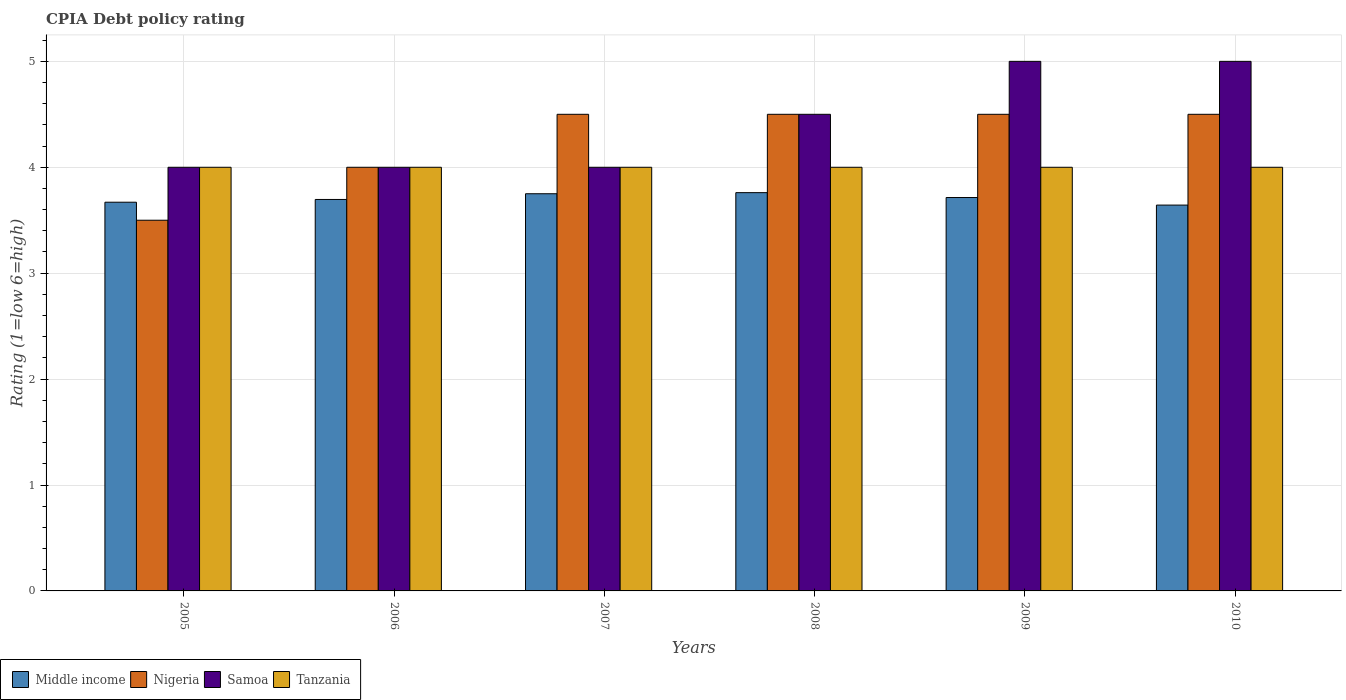How many different coloured bars are there?
Offer a very short reply. 4. Across all years, what is the maximum CPIA rating in Tanzania?
Ensure brevity in your answer.  4. Across all years, what is the minimum CPIA rating in Tanzania?
Your answer should be compact. 4. What is the total CPIA rating in Samoa in the graph?
Your answer should be compact. 26.5. What is the difference between the CPIA rating in Tanzania in 2005 and that in 2009?
Your answer should be very brief. 0. What is the difference between the CPIA rating in Tanzania in 2009 and the CPIA rating in Middle income in 2006?
Provide a succinct answer. 0.3. What is the average CPIA rating in Tanzania per year?
Offer a terse response. 4. What is the ratio of the CPIA rating in Samoa in 2007 to that in 2008?
Your answer should be very brief. 0.89. Is the difference between the CPIA rating in Nigeria in 2005 and 2006 greater than the difference between the CPIA rating in Samoa in 2005 and 2006?
Keep it short and to the point. No. What is the difference between the highest and the lowest CPIA rating in Nigeria?
Offer a terse response. 1. Is it the case that in every year, the sum of the CPIA rating in Middle income and CPIA rating in Tanzania is greater than the sum of CPIA rating in Samoa and CPIA rating in Nigeria?
Provide a succinct answer. No. What does the 3rd bar from the left in 2009 represents?
Keep it short and to the point. Samoa. What does the 3rd bar from the right in 2007 represents?
Your answer should be compact. Nigeria. How many bars are there?
Give a very brief answer. 24. Are all the bars in the graph horizontal?
Offer a very short reply. No. What is the difference between two consecutive major ticks on the Y-axis?
Your response must be concise. 1. Does the graph contain any zero values?
Ensure brevity in your answer.  No. Where does the legend appear in the graph?
Offer a terse response. Bottom left. What is the title of the graph?
Offer a very short reply. CPIA Debt policy rating. What is the label or title of the X-axis?
Make the answer very short. Years. What is the label or title of the Y-axis?
Provide a succinct answer. Rating (1=low 6=high). What is the Rating (1=low 6=high) in Middle income in 2005?
Ensure brevity in your answer.  3.67. What is the Rating (1=low 6=high) in Nigeria in 2005?
Provide a short and direct response. 3.5. What is the Rating (1=low 6=high) in Middle income in 2006?
Your response must be concise. 3.7. What is the Rating (1=low 6=high) in Nigeria in 2006?
Your answer should be very brief. 4. What is the Rating (1=low 6=high) of Samoa in 2006?
Your answer should be compact. 4. What is the Rating (1=low 6=high) of Tanzania in 2006?
Ensure brevity in your answer.  4. What is the Rating (1=low 6=high) of Middle income in 2007?
Your response must be concise. 3.75. What is the Rating (1=low 6=high) in Samoa in 2007?
Your answer should be compact. 4. What is the Rating (1=low 6=high) of Tanzania in 2007?
Make the answer very short. 4. What is the Rating (1=low 6=high) in Middle income in 2008?
Your answer should be compact. 3.76. What is the Rating (1=low 6=high) in Tanzania in 2008?
Make the answer very short. 4. What is the Rating (1=low 6=high) of Middle income in 2009?
Provide a short and direct response. 3.71. What is the Rating (1=low 6=high) of Middle income in 2010?
Offer a terse response. 3.64. What is the Rating (1=low 6=high) in Nigeria in 2010?
Provide a short and direct response. 4.5. Across all years, what is the maximum Rating (1=low 6=high) of Middle income?
Provide a short and direct response. 3.76. Across all years, what is the maximum Rating (1=low 6=high) in Nigeria?
Make the answer very short. 4.5. Across all years, what is the maximum Rating (1=low 6=high) in Samoa?
Your answer should be compact. 5. Across all years, what is the minimum Rating (1=low 6=high) in Middle income?
Your answer should be compact. 3.64. Across all years, what is the minimum Rating (1=low 6=high) of Nigeria?
Offer a very short reply. 3.5. Across all years, what is the minimum Rating (1=low 6=high) of Samoa?
Ensure brevity in your answer.  4. Across all years, what is the minimum Rating (1=low 6=high) of Tanzania?
Keep it short and to the point. 4. What is the total Rating (1=low 6=high) of Middle income in the graph?
Your answer should be compact. 22.23. What is the total Rating (1=low 6=high) of Samoa in the graph?
Your response must be concise. 26.5. What is the difference between the Rating (1=low 6=high) of Middle income in 2005 and that in 2006?
Offer a very short reply. -0.03. What is the difference between the Rating (1=low 6=high) in Nigeria in 2005 and that in 2006?
Ensure brevity in your answer.  -0.5. What is the difference between the Rating (1=low 6=high) of Samoa in 2005 and that in 2006?
Provide a short and direct response. 0. What is the difference between the Rating (1=low 6=high) in Tanzania in 2005 and that in 2006?
Offer a terse response. 0. What is the difference between the Rating (1=low 6=high) in Middle income in 2005 and that in 2007?
Make the answer very short. -0.08. What is the difference between the Rating (1=low 6=high) in Nigeria in 2005 and that in 2007?
Provide a succinct answer. -1. What is the difference between the Rating (1=low 6=high) of Tanzania in 2005 and that in 2007?
Your response must be concise. 0. What is the difference between the Rating (1=low 6=high) of Middle income in 2005 and that in 2008?
Keep it short and to the point. -0.09. What is the difference between the Rating (1=low 6=high) in Nigeria in 2005 and that in 2008?
Your answer should be compact. -1. What is the difference between the Rating (1=low 6=high) of Tanzania in 2005 and that in 2008?
Make the answer very short. 0. What is the difference between the Rating (1=low 6=high) in Middle income in 2005 and that in 2009?
Offer a very short reply. -0.04. What is the difference between the Rating (1=low 6=high) of Nigeria in 2005 and that in 2009?
Your answer should be very brief. -1. What is the difference between the Rating (1=low 6=high) in Middle income in 2005 and that in 2010?
Your answer should be compact. 0.03. What is the difference between the Rating (1=low 6=high) of Samoa in 2005 and that in 2010?
Your response must be concise. -1. What is the difference between the Rating (1=low 6=high) of Middle income in 2006 and that in 2007?
Keep it short and to the point. -0.05. What is the difference between the Rating (1=low 6=high) in Middle income in 2006 and that in 2008?
Ensure brevity in your answer.  -0.06. What is the difference between the Rating (1=low 6=high) in Nigeria in 2006 and that in 2008?
Provide a short and direct response. -0.5. What is the difference between the Rating (1=low 6=high) in Middle income in 2006 and that in 2009?
Provide a short and direct response. -0.02. What is the difference between the Rating (1=low 6=high) in Nigeria in 2006 and that in 2009?
Provide a short and direct response. -0.5. What is the difference between the Rating (1=low 6=high) of Samoa in 2006 and that in 2009?
Offer a very short reply. -1. What is the difference between the Rating (1=low 6=high) in Tanzania in 2006 and that in 2009?
Ensure brevity in your answer.  0. What is the difference between the Rating (1=low 6=high) of Middle income in 2006 and that in 2010?
Ensure brevity in your answer.  0.05. What is the difference between the Rating (1=low 6=high) in Middle income in 2007 and that in 2008?
Your answer should be very brief. -0.01. What is the difference between the Rating (1=low 6=high) in Nigeria in 2007 and that in 2008?
Make the answer very short. 0. What is the difference between the Rating (1=low 6=high) of Tanzania in 2007 and that in 2008?
Your answer should be compact. 0. What is the difference between the Rating (1=low 6=high) of Middle income in 2007 and that in 2009?
Provide a succinct answer. 0.04. What is the difference between the Rating (1=low 6=high) in Nigeria in 2007 and that in 2009?
Make the answer very short. 0. What is the difference between the Rating (1=low 6=high) in Samoa in 2007 and that in 2009?
Your response must be concise. -1. What is the difference between the Rating (1=low 6=high) in Tanzania in 2007 and that in 2009?
Your answer should be compact. 0. What is the difference between the Rating (1=low 6=high) of Middle income in 2007 and that in 2010?
Ensure brevity in your answer.  0.11. What is the difference between the Rating (1=low 6=high) of Middle income in 2008 and that in 2009?
Provide a short and direct response. 0.05. What is the difference between the Rating (1=low 6=high) in Middle income in 2008 and that in 2010?
Your response must be concise. 0.12. What is the difference between the Rating (1=low 6=high) of Nigeria in 2008 and that in 2010?
Your answer should be compact. 0. What is the difference between the Rating (1=low 6=high) of Samoa in 2008 and that in 2010?
Offer a terse response. -0.5. What is the difference between the Rating (1=low 6=high) of Middle income in 2009 and that in 2010?
Give a very brief answer. 0.07. What is the difference between the Rating (1=low 6=high) in Nigeria in 2009 and that in 2010?
Keep it short and to the point. 0. What is the difference between the Rating (1=low 6=high) of Middle income in 2005 and the Rating (1=low 6=high) of Nigeria in 2006?
Make the answer very short. -0.33. What is the difference between the Rating (1=low 6=high) in Middle income in 2005 and the Rating (1=low 6=high) in Samoa in 2006?
Make the answer very short. -0.33. What is the difference between the Rating (1=low 6=high) of Middle income in 2005 and the Rating (1=low 6=high) of Tanzania in 2006?
Make the answer very short. -0.33. What is the difference between the Rating (1=low 6=high) in Nigeria in 2005 and the Rating (1=low 6=high) in Tanzania in 2006?
Your answer should be very brief. -0.5. What is the difference between the Rating (1=low 6=high) in Samoa in 2005 and the Rating (1=low 6=high) in Tanzania in 2006?
Provide a short and direct response. 0. What is the difference between the Rating (1=low 6=high) of Middle income in 2005 and the Rating (1=low 6=high) of Nigeria in 2007?
Provide a succinct answer. -0.83. What is the difference between the Rating (1=low 6=high) of Middle income in 2005 and the Rating (1=low 6=high) of Samoa in 2007?
Keep it short and to the point. -0.33. What is the difference between the Rating (1=low 6=high) of Middle income in 2005 and the Rating (1=low 6=high) of Tanzania in 2007?
Your response must be concise. -0.33. What is the difference between the Rating (1=low 6=high) of Middle income in 2005 and the Rating (1=low 6=high) of Nigeria in 2008?
Keep it short and to the point. -0.83. What is the difference between the Rating (1=low 6=high) of Middle income in 2005 and the Rating (1=low 6=high) of Samoa in 2008?
Make the answer very short. -0.83. What is the difference between the Rating (1=low 6=high) in Middle income in 2005 and the Rating (1=low 6=high) in Tanzania in 2008?
Your answer should be compact. -0.33. What is the difference between the Rating (1=low 6=high) of Nigeria in 2005 and the Rating (1=low 6=high) of Samoa in 2008?
Offer a terse response. -1. What is the difference between the Rating (1=low 6=high) in Nigeria in 2005 and the Rating (1=low 6=high) in Tanzania in 2008?
Ensure brevity in your answer.  -0.5. What is the difference between the Rating (1=low 6=high) in Middle income in 2005 and the Rating (1=low 6=high) in Nigeria in 2009?
Give a very brief answer. -0.83. What is the difference between the Rating (1=low 6=high) of Middle income in 2005 and the Rating (1=low 6=high) of Samoa in 2009?
Ensure brevity in your answer.  -1.33. What is the difference between the Rating (1=low 6=high) in Middle income in 2005 and the Rating (1=low 6=high) in Tanzania in 2009?
Provide a succinct answer. -0.33. What is the difference between the Rating (1=low 6=high) of Nigeria in 2005 and the Rating (1=low 6=high) of Tanzania in 2009?
Offer a very short reply. -0.5. What is the difference between the Rating (1=low 6=high) of Middle income in 2005 and the Rating (1=low 6=high) of Nigeria in 2010?
Keep it short and to the point. -0.83. What is the difference between the Rating (1=low 6=high) in Middle income in 2005 and the Rating (1=low 6=high) in Samoa in 2010?
Your response must be concise. -1.33. What is the difference between the Rating (1=low 6=high) of Middle income in 2005 and the Rating (1=low 6=high) of Tanzania in 2010?
Offer a very short reply. -0.33. What is the difference between the Rating (1=low 6=high) in Nigeria in 2005 and the Rating (1=low 6=high) in Samoa in 2010?
Offer a very short reply. -1.5. What is the difference between the Rating (1=low 6=high) of Samoa in 2005 and the Rating (1=low 6=high) of Tanzania in 2010?
Your answer should be compact. 0. What is the difference between the Rating (1=low 6=high) of Middle income in 2006 and the Rating (1=low 6=high) of Nigeria in 2007?
Keep it short and to the point. -0.8. What is the difference between the Rating (1=low 6=high) of Middle income in 2006 and the Rating (1=low 6=high) of Samoa in 2007?
Ensure brevity in your answer.  -0.3. What is the difference between the Rating (1=low 6=high) in Middle income in 2006 and the Rating (1=low 6=high) in Tanzania in 2007?
Keep it short and to the point. -0.3. What is the difference between the Rating (1=low 6=high) of Samoa in 2006 and the Rating (1=low 6=high) of Tanzania in 2007?
Make the answer very short. 0. What is the difference between the Rating (1=low 6=high) of Middle income in 2006 and the Rating (1=low 6=high) of Nigeria in 2008?
Provide a succinct answer. -0.8. What is the difference between the Rating (1=low 6=high) in Middle income in 2006 and the Rating (1=low 6=high) in Samoa in 2008?
Provide a succinct answer. -0.8. What is the difference between the Rating (1=low 6=high) of Middle income in 2006 and the Rating (1=low 6=high) of Tanzania in 2008?
Provide a short and direct response. -0.3. What is the difference between the Rating (1=low 6=high) in Nigeria in 2006 and the Rating (1=low 6=high) in Tanzania in 2008?
Make the answer very short. 0. What is the difference between the Rating (1=low 6=high) in Samoa in 2006 and the Rating (1=low 6=high) in Tanzania in 2008?
Offer a very short reply. 0. What is the difference between the Rating (1=low 6=high) in Middle income in 2006 and the Rating (1=low 6=high) in Nigeria in 2009?
Make the answer very short. -0.8. What is the difference between the Rating (1=low 6=high) of Middle income in 2006 and the Rating (1=low 6=high) of Samoa in 2009?
Give a very brief answer. -1.3. What is the difference between the Rating (1=low 6=high) in Middle income in 2006 and the Rating (1=low 6=high) in Tanzania in 2009?
Ensure brevity in your answer.  -0.3. What is the difference between the Rating (1=low 6=high) in Middle income in 2006 and the Rating (1=low 6=high) in Nigeria in 2010?
Give a very brief answer. -0.8. What is the difference between the Rating (1=low 6=high) of Middle income in 2006 and the Rating (1=low 6=high) of Samoa in 2010?
Offer a very short reply. -1.3. What is the difference between the Rating (1=low 6=high) in Middle income in 2006 and the Rating (1=low 6=high) in Tanzania in 2010?
Your answer should be very brief. -0.3. What is the difference between the Rating (1=low 6=high) of Nigeria in 2006 and the Rating (1=low 6=high) of Samoa in 2010?
Give a very brief answer. -1. What is the difference between the Rating (1=low 6=high) in Nigeria in 2006 and the Rating (1=low 6=high) in Tanzania in 2010?
Give a very brief answer. 0. What is the difference between the Rating (1=low 6=high) of Middle income in 2007 and the Rating (1=low 6=high) of Nigeria in 2008?
Give a very brief answer. -0.75. What is the difference between the Rating (1=low 6=high) of Middle income in 2007 and the Rating (1=low 6=high) of Samoa in 2008?
Your answer should be compact. -0.75. What is the difference between the Rating (1=low 6=high) in Middle income in 2007 and the Rating (1=low 6=high) in Tanzania in 2008?
Give a very brief answer. -0.25. What is the difference between the Rating (1=low 6=high) in Nigeria in 2007 and the Rating (1=low 6=high) in Samoa in 2008?
Your answer should be compact. 0. What is the difference between the Rating (1=low 6=high) in Middle income in 2007 and the Rating (1=low 6=high) in Nigeria in 2009?
Provide a succinct answer. -0.75. What is the difference between the Rating (1=low 6=high) in Middle income in 2007 and the Rating (1=low 6=high) in Samoa in 2009?
Make the answer very short. -1.25. What is the difference between the Rating (1=low 6=high) of Middle income in 2007 and the Rating (1=low 6=high) of Tanzania in 2009?
Your answer should be compact. -0.25. What is the difference between the Rating (1=low 6=high) of Middle income in 2007 and the Rating (1=low 6=high) of Nigeria in 2010?
Offer a very short reply. -0.75. What is the difference between the Rating (1=low 6=high) in Middle income in 2007 and the Rating (1=low 6=high) in Samoa in 2010?
Provide a succinct answer. -1.25. What is the difference between the Rating (1=low 6=high) in Nigeria in 2007 and the Rating (1=low 6=high) in Samoa in 2010?
Offer a very short reply. -0.5. What is the difference between the Rating (1=low 6=high) in Nigeria in 2007 and the Rating (1=low 6=high) in Tanzania in 2010?
Your answer should be compact. 0.5. What is the difference between the Rating (1=low 6=high) of Samoa in 2007 and the Rating (1=low 6=high) of Tanzania in 2010?
Ensure brevity in your answer.  0. What is the difference between the Rating (1=low 6=high) in Middle income in 2008 and the Rating (1=low 6=high) in Nigeria in 2009?
Offer a terse response. -0.74. What is the difference between the Rating (1=low 6=high) in Middle income in 2008 and the Rating (1=low 6=high) in Samoa in 2009?
Ensure brevity in your answer.  -1.24. What is the difference between the Rating (1=low 6=high) of Middle income in 2008 and the Rating (1=low 6=high) of Tanzania in 2009?
Make the answer very short. -0.24. What is the difference between the Rating (1=low 6=high) in Middle income in 2008 and the Rating (1=low 6=high) in Nigeria in 2010?
Ensure brevity in your answer.  -0.74. What is the difference between the Rating (1=low 6=high) of Middle income in 2008 and the Rating (1=low 6=high) of Samoa in 2010?
Keep it short and to the point. -1.24. What is the difference between the Rating (1=low 6=high) in Middle income in 2008 and the Rating (1=low 6=high) in Tanzania in 2010?
Provide a succinct answer. -0.24. What is the difference between the Rating (1=low 6=high) of Nigeria in 2008 and the Rating (1=low 6=high) of Tanzania in 2010?
Offer a terse response. 0.5. What is the difference between the Rating (1=low 6=high) in Samoa in 2008 and the Rating (1=low 6=high) in Tanzania in 2010?
Offer a terse response. 0.5. What is the difference between the Rating (1=low 6=high) of Middle income in 2009 and the Rating (1=low 6=high) of Nigeria in 2010?
Your answer should be very brief. -0.79. What is the difference between the Rating (1=low 6=high) of Middle income in 2009 and the Rating (1=low 6=high) of Samoa in 2010?
Your answer should be compact. -1.29. What is the difference between the Rating (1=low 6=high) of Middle income in 2009 and the Rating (1=low 6=high) of Tanzania in 2010?
Ensure brevity in your answer.  -0.29. What is the average Rating (1=low 6=high) in Middle income per year?
Give a very brief answer. 3.71. What is the average Rating (1=low 6=high) of Nigeria per year?
Ensure brevity in your answer.  4.25. What is the average Rating (1=low 6=high) in Samoa per year?
Offer a very short reply. 4.42. What is the average Rating (1=low 6=high) in Tanzania per year?
Keep it short and to the point. 4. In the year 2005, what is the difference between the Rating (1=low 6=high) in Middle income and Rating (1=low 6=high) in Nigeria?
Your response must be concise. 0.17. In the year 2005, what is the difference between the Rating (1=low 6=high) of Middle income and Rating (1=low 6=high) of Samoa?
Your response must be concise. -0.33. In the year 2005, what is the difference between the Rating (1=low 6=high) of Middle income and Rating (1=low 6=high) of Tanzania?
Your answer should be compact. -0.33. In the year 2005, what is the difference between the Rating (1=low 6=high) of Nigeria and Rating (1=low 6=high) of Tanzania?
Your response must be concise. -0.5. In the year 2005, what is the difference between the Rating (1=low 6=high) in Samoa and Rating (1=low 6=high) in Tanzania?
Ensure brevity in your answer.  0. In the year 2006, what is the difference between the Rating (1=low 6=high) of Middle income and Rating (1=low 6=high) of Nigeria?
Keep it short and to the point. -0.3. In the year 2006, what is the difference between the Rating (1=low 6=high) in Middle income and Rating (1=low 6=high) in Samoa?
Your response must be concise. -0.3. In the year 2006, what is the difference between the Rating (1=low 6=high) of Middle income and Rating (1=low 6=high) of Tanzania?
Make the answer very short. -0.3. In the year 2006, what is the difference between the Rating (1=low 6=high) of Nigeria and Rating (1=low 6=high) of Samoa?
Give a very brief answer. 0. In the year 2006, what is the difference between the Rating (1=low 6=high) in Nigeria and Rating (1=low 6=high) in Tanzania?
Keep it short and to the point. 0. In the year 2007, what is the difference between the Rating (1=low 6=high) of Middle income and Rating (1=low 6=high) of Nigeria?
Your response must be concise. -0.75. In the year 2007, what is the difference between the Rating (1=low 6=high) of Nigeria and Rating (1=low 6=high) of Samoa?
Offer a very short reply. 0.5. In the year 2007, what is the difference between the Rating (1=low 6=high) in Nigeria and Rating (1=low 6=high) in Tanzania?
Offer a terse response. 0.5. In the year 2007, what is the difference between the Rating (1=low 6=high) in Samoa and Rating (1=low 6=high) in Tanzania?
Provide a short and direct response. 0. In the year 2008, what is the difference between the Rating (1=low 6=high) in Middle income and Rating (1=low 6=high) in Nigeria?
Keep it short and to the point. -0.74. In the year 2008, what is the difference between the Rating (1=low 6=high) in Middle income and Rating (1=low 6=high) in Samoa?
Your answer should be very brief. -0.74. In the year 2008, what is the difference between the Rating (1=low 6=high) of Middle income and Rating (1=low 6=high) of Tanzania?
Provide a short and direct response. -0.24. In the year 2008, what is the difference between the Rating (1=low 6=high) of Nigeria and Rating (1=low 6=high) of Tanzania?
Offer a terse response. 0.5. In the year 2009, what is the difference between the Rating (1=low 6=high) in Middle income and Rating (1=low 6=high) in Nigeria?
Ensure brevity in your answer.  -0.79. In the year 2009, what is the difference between the Rating (1=low 6=high) of Middle income and Rating (1=low 6=high) of Samoa?
Offer a terse response. -1.29. In the year 2009, what is the difference between the Rating (1=low 6=high) of Middle income and Rating (1=low 6=high) of Tanzania?
Offer a terse response. -0.29. In the year 2009, what is the difference between the Rating (1=low 6=high) in Nigeria and Rating (1=low 6=high) in Samoa?
Your answer should be compact. -0.5. In the year 2009, what is the difference between the Rating (1=low 6=high) in Nigeria and Rating (1=low 6=high) in Tanzania?
Give a very brief answer. 0.5. In the year 2010, what is the difference between the Rating (1=low 6=high) of Middle income and Rating (1=low 6=high) of Nigeria?
Offer a terse response. -0.86. In the year 2010, what is the difference between the Rating (1=low 6=high) of Middle income and Rating (1=low 6=high) of Samoa?
Provide a succinct answer. -1.36. In the year 2010, what is the difference between the Rating (1=low 6=high) of Middle income and Rating (1=low 6=high) of Tanzania?
Your answer should be very brief. -0.36. In the year 2010, what is the difference between the Rating (1=low 6=high) in Nigeria and Rating (1=low 6=high) in Samoa?
Keep it short and to the point. -0.5. In the year 2010, what is the difference between the Rating (1=low 6=high) of Nigeria and Rating (1=low 6=high) of Tanzania?
Ensure brevity in your answer.  0.5. In the year 2010, what is the difference between the Rating (1=low 6=high) of Samoa and Rating (1=low 6=high) of Tanzania?
Provide a short and direct response. 1. What is the ratio of the Rating (1=low 6=high) of Middle income in 2005 to that in 2006?
Keep it short and to the point. 0.99. What is the ratio of the Rating (1=low 6=high) in Middle income in 2005 to that in 2007?
Give a very brief answer. 0.98. What is the ratio of the Rating (1=low 6=high) in Middle income in 2005 to that in 2008?
Offer a terse response. 0.98. What is the ratio of the Rating (1=low 6=high) in Nigeria in 2005 to that in 2008?
Provide a succinct answer. 0.78. What is the ratio of the Rating (1=low 6=high) of Middle income in 2005 to that in 2010?
Offer a very short reply. 1.01. What is the ratio of the Rating (1=low 6=high) of Nigeria in 2005 to that in 2010?
Make the answer very short. 0.78. What is the ratio of the Rating (1=low 6=high) in Samoa in 2005 to that in 2010?
Your answer should be compact. 0.8. What is the ratio of the Rating (1=low 6=high) in Middle income in 2006 to that in 2007?
Ensure brevity in your answer.  0.99. What is the ratio of the Rating (1=low 6=high) in Samoa in 2006 to that in 2007?
Make the answer very short. 1. What is the ratio of the Rating (1=low 6=high) of Middle income in 2006 to that in 2008?
Provide a succinct answer. 0.98. What is the ratio of the Rating (1=low 6=high) in Tanzania in 2006 to that in 2008?
Offer a terse response. 1. What is the ratio of the Rating (1=low 6=high) in Middle income in 2006 to that in 2009?
Provide a short and direct response. 1. What is the ratio of the Rating (1=low 6=high) of Nigeria in 2006 to that in 2009?
Your response must be concise. 0.89. What is the ratio of the Rating (1=low 6=high) in Middle income in 2006 to that in 2010?
Offer a very short reply. 1.01. What is the ratio of the Rating (1=low 6=high) in Samoa in 2006 to that in 2010?
Provide a short and direct response. 0.8. What is the ratio of the Rating (1=low 6=high) in Tanzania in 2006 to that in 2010?
Offer a very short reply. 1. What is the ratio of the Rating (1=low 6=high) in Nigeria in 2007 to that in 2008?
Keep it short and to the point. 1. What is the ratio of the Rating (1=low 6=high) of Samoa in 2007 to that in 2008?
Ensure brevity in your answer.  0.89. What is the ratio of the Rating (1=low 6=high) of Middle income in 2007 to that in 2009?
Your answer should be very brief. 1.01. What is the ratio of the Rating (1=low 6=high) in Nigeria in 2007 to that in 2009?
Your answer should be very brief. 1. What is the ratio of the Rating (1=low 6=high) in Samoa in 2007 to that in 2009?
Provide a succinct answer. 0.8. What is the ratio of the Rating (1=low 6=high) of Middle income in 2007 to that in 2010?
Give a very brief answer. 1.03. What is the ratio of the Rating (1=low 6=high) in Nigeria in 2007 to that in 2010?
Provide a succinct answer. 1. What is the ratio of the Rating (1=low 6=high) in Tanzania in 2007 to that in 2010?
Your answer should be compact. 1. What is the ratio of the Rating (1=low 6=high) in Middle income in 2008 to that in 2009?
Provide a succinct answer. 1.01. What is the ratio of the Rating (1=low 6=high) of Samoa in 2008 to that in 2009?
Your response must be concise. 0.9. What is the ratio of the Rating (1=low 6=high) of Middle income in 2008 to that in 2010?
Your response must be concise. 1.03. What is the ratio of the Rating (1=low 6=high) of Nigeria in 2008 to that in 2010?
Provide a succinct answer. 1. What is the ratio of the Rating (1=low 6=high) of Samoa in 2008 to that in 2010?
Your answer should be compact. 0.9. What is the ratio of the Rating (1=low 6=high) of Tanzania in 2008 to that in 2010?
Your answer should be compact. 1. What is the ratio of the Rating (1=low 6=high) of Middle income in 2009 to that in 2010?
Your answer should be very brief. 1.02. What is the ratio of the Rating (1=low 6=high) in Nigeria in 2009 to that in 2010?
Ensure brevity in your answer.  1. What is the difference between the highest and the second highest Rating (1=low 6=high) of Middle income?
Your answer should be very brief. 0.01. What is the difference between the highest and the second highest Rating (1=low 6=high) of Nigeria?
Your response must be concise. 0. What is the difference between the highest and the second highest Rating (1=low 6=high) of Samoa?
Your response must be concise. 0. What is the difference between the highest and the lowest Rating (1=low 6=high) of Middle income?
Provide a succinct answer. 0.12. What is the difference between the highest and the lowest Rating (1=low 6=high) in Tanzania?
Provide a succinct answer. 0. 